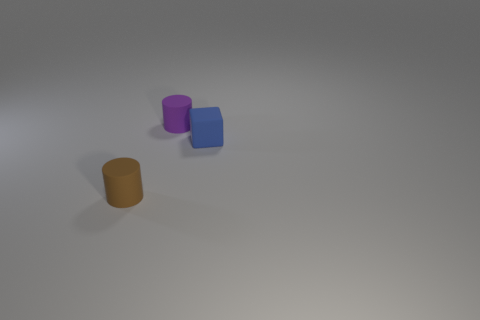Add 2 small brown rubber cylinders. How many objects exist? 5 Subtract 1 blocks. How many blocks are left? 0 Subtract all cylinders. How many objects are left? 1 Subtract all brown cylinders. How many cylinders are left? 1 Subtract all small metallic balls. Subtract all purple cylinders. How many objects are left? 2 Add 3 blue matte cubes. How many blue matte cubes are left? 4 Add 3 brown matte cylinders. How many brown matte cylinders exist? 4 Subtract 0 red cylinders. How many objects are left? 3 Subtract all cyan cubes. Subtract all yellow cylinders. How many cubes are left? 1 